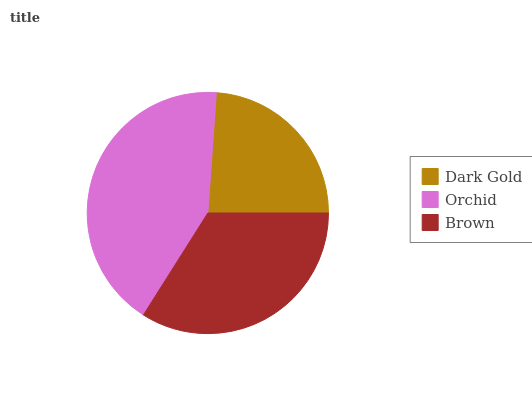Is Dark Gold the minimum?
Answer yes or no. Yes. Is Orchid the maximum?
Answer yes or no. Yes. Is Brown the minimum?
Answer yes or no. No. Is Brown the maximum?
Answer yes or no. No. Is Orchid greater than Brown?
Answer yes or no. Yes. Is Brown less than Orchid?
Answer yes or no. Yes. Is Brown greater than Orchid?
Answer yes or no. No. Is Orchid less than Brown?
Answer yes or no. No. Is Brown the high median?
Answer yes or no. Yes. Is Brown the low median?
Answer yes or no. Yes. Is Orchid the high median?
Answer yes or no. No. Is Orchid the low median?
Answer yes or no. No. 